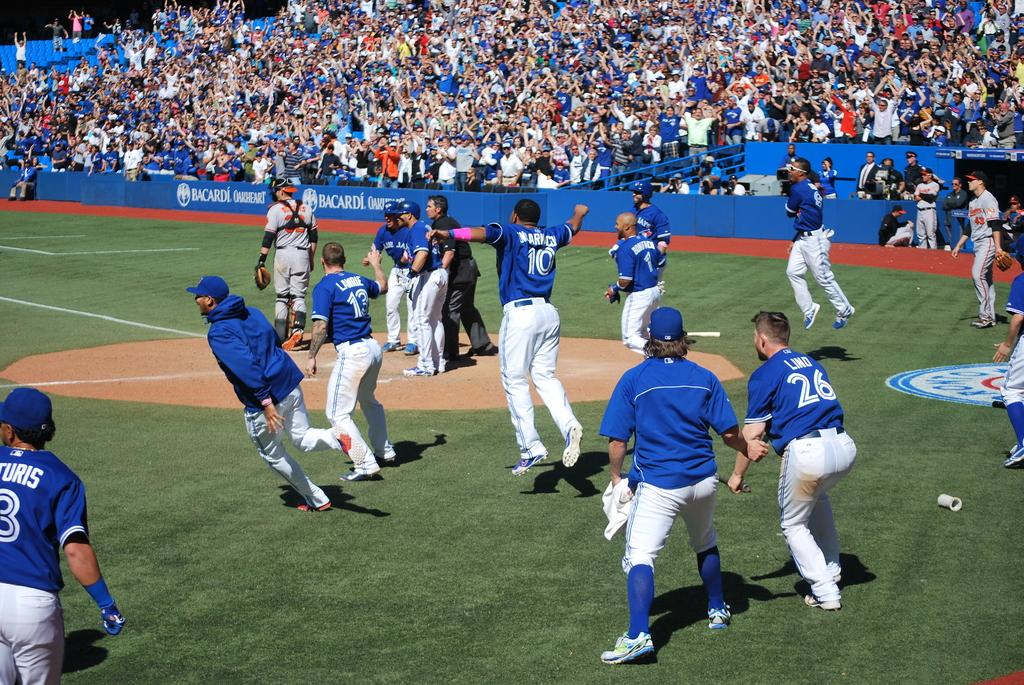<image>
Summarize the visual content of the image. Baseball players on a field including number 10. 